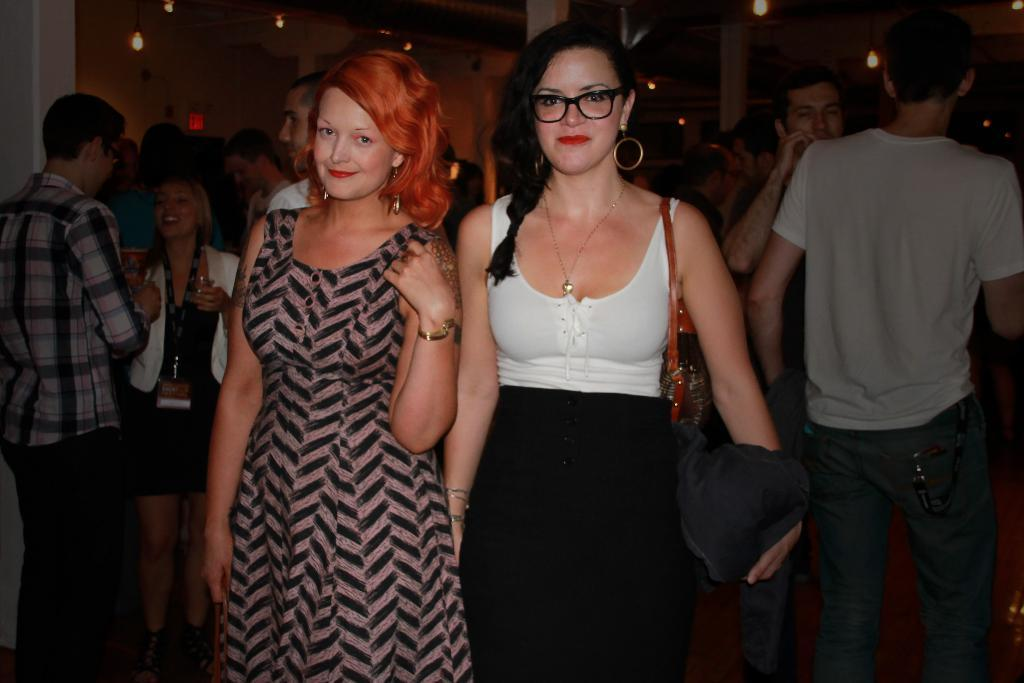How many people are posing for a photo in the image? There are two persons standing and posing for a photo in the image. What is the setting of the photo? The people are standing in a room. What feature can be seen on the ceiling of the room? There are lights attached to the ceiling in the room. What type of yoke is being used by the person in the image? There is no yoke present in the image; it features two people posing for a photo in a room with lights attached to the ceiling. 